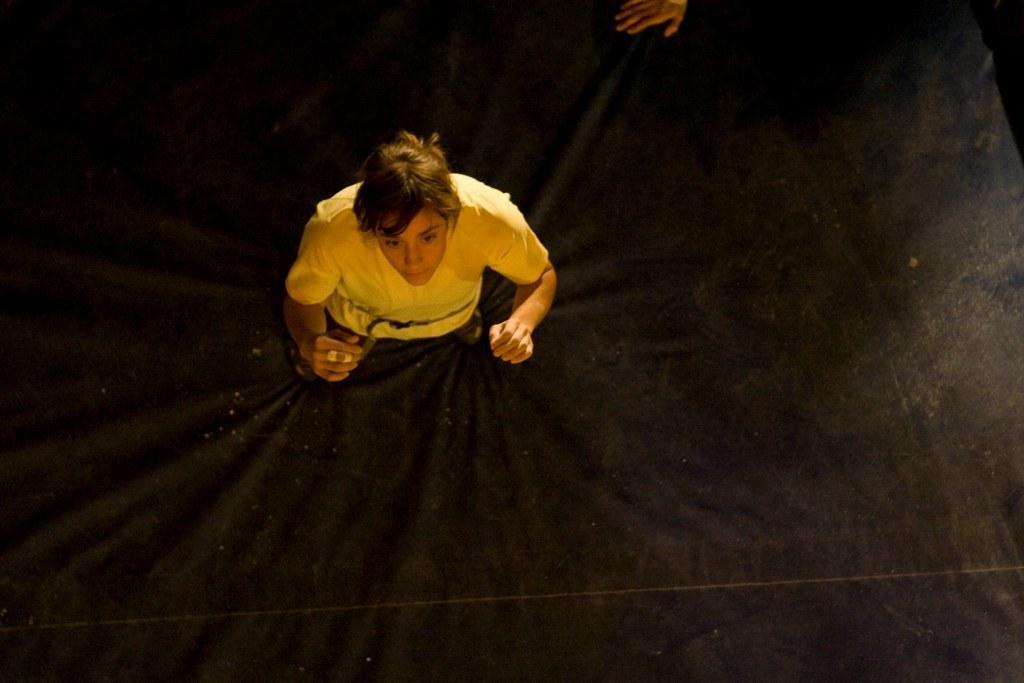Could you give a brief overview of what you see in this image? In the middle I can see a person, cloth and a person's hand. This image is taken may be during night. 